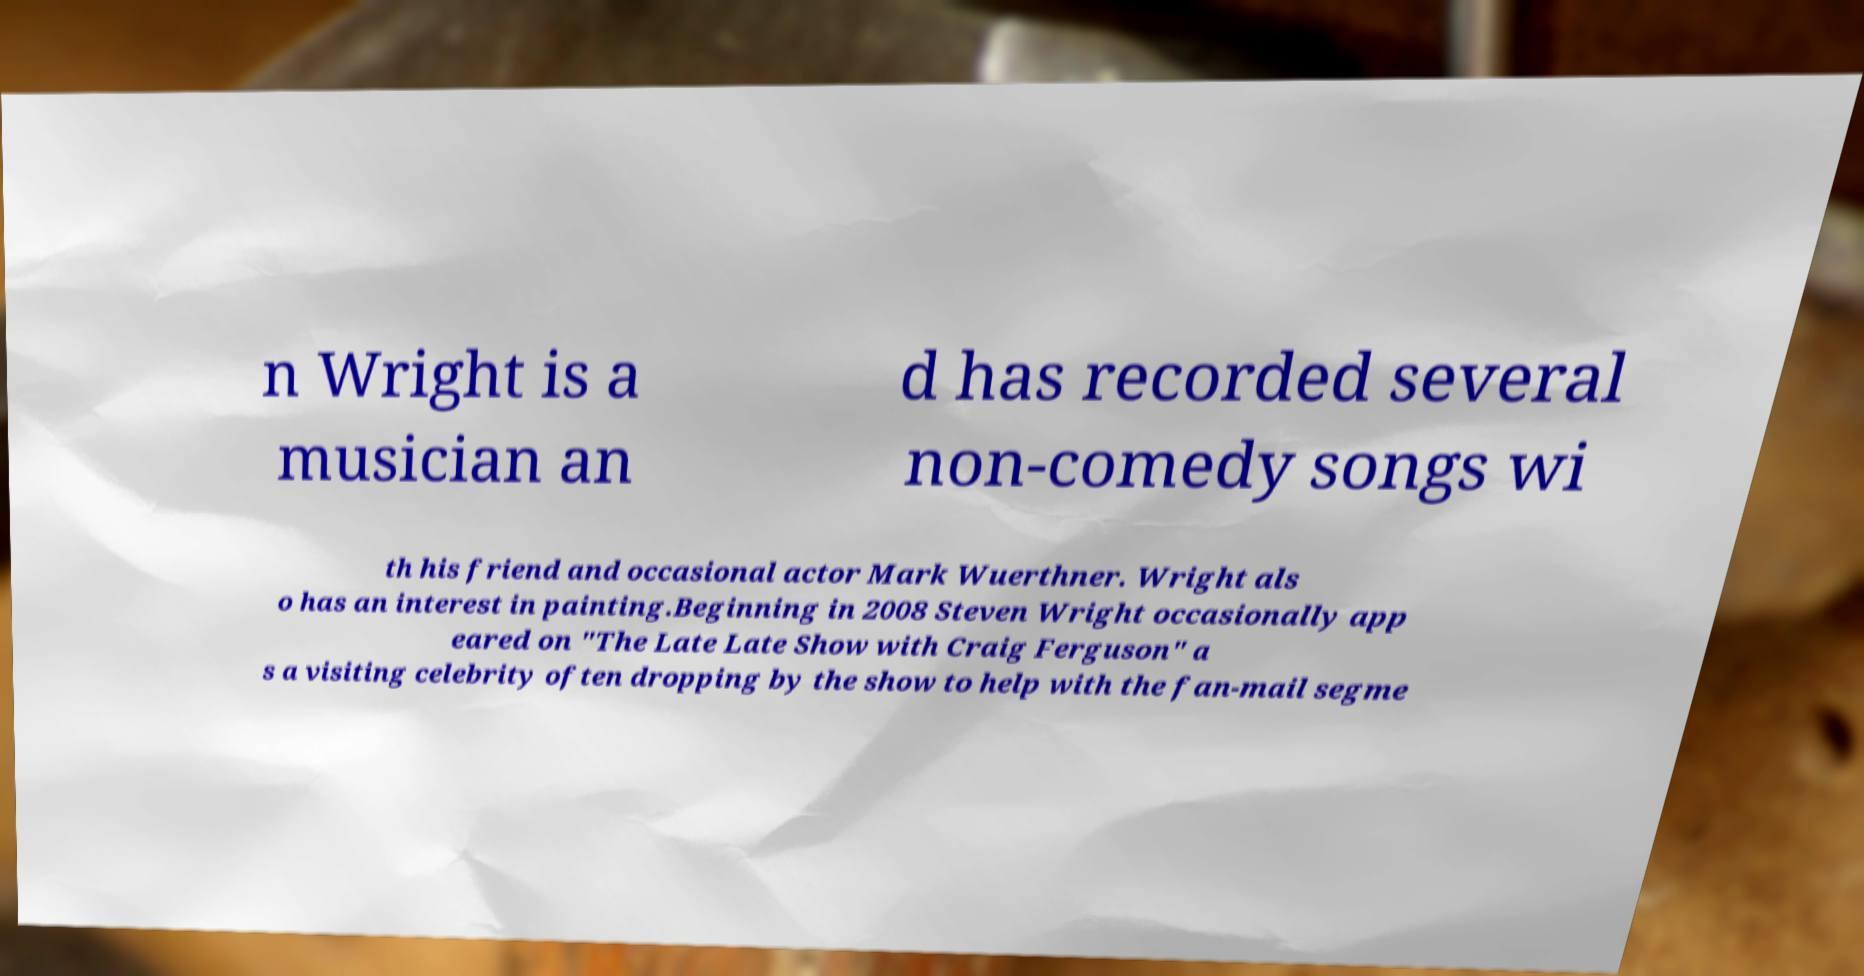Could you extract and type out the text from this image? n Wright is a musician an d has recorded several non-comedy songs wi th his friend and occasional actor Mark Wuerthner. Wright als o has an interest in painting.Beginning in 2008 Steven Wright occasionally app eared on "The Late Late Show with Craig Ferguson" a s a visiting celebrity often dropping by the show to help with the fan-mail segme 